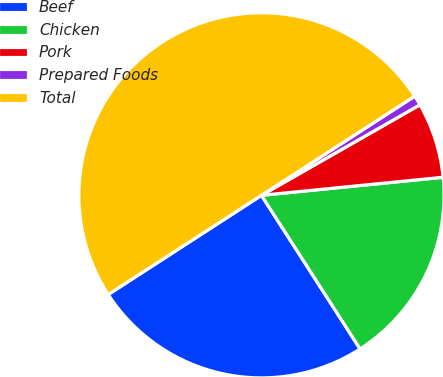<chart> <loc_0><loc_0><loc_500><loc_500><pie_chart><fcel>Beef<fcel>Chicken<fcel>Pork<fcel>Prepared Foods<fcel>Total<nl><fcel>24.94%<fcel>17.49%<fcel>6.68%<fcel>0.88%<fcel>50.0%<nl></chart> 